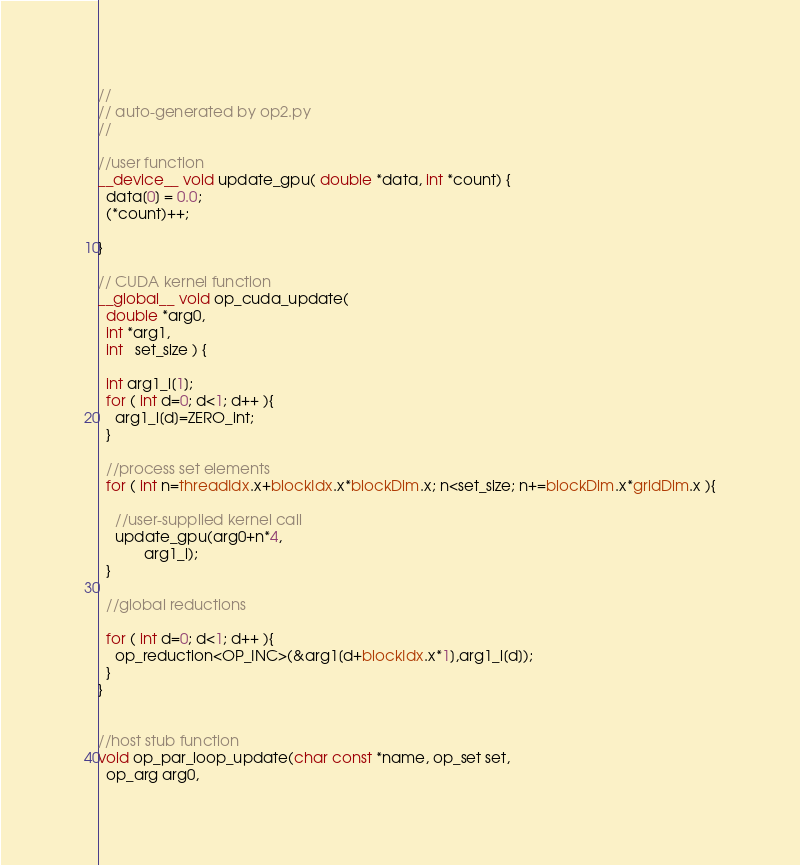Convert code to text. <code><loc_0><loc_0><loc_500><loc_500><_Cuda_>//
// auto-generated by op2.py
//

//user function
__device__ void update_gpu( double *data, int *count) {
  data[0] = 0.0;
  (*count)++;

}

// CUDA kernel function
__global__ void op_cuda_update(
  double *arg0,
  int *arg1,
  int   set_size ) {

  int arg1_l[1];
  for ( int d=0; d<1; d++ ){
    arg1_l[d]=ZERO_int;
  }

  //process set elements
  for ( int n=threadIdx.x+blockIdx.x*blockDim.x; n<set_size; n+=blockDim.x*gridDim.x ){

    //user-supplied kernel call
    update_gpu(arg0+n*4,
           arg1_l);
  }

  //global reductions

  for ( int d=0; d<1; d++ ){
    op_reduction<OP_INC>(&arg1[d+blockIdx.x*1],arg1_l[d]);
  }
}


//host stub function
void op_par_loop_update(char const *name, op_set set,
  op_arg arg0,</code> 